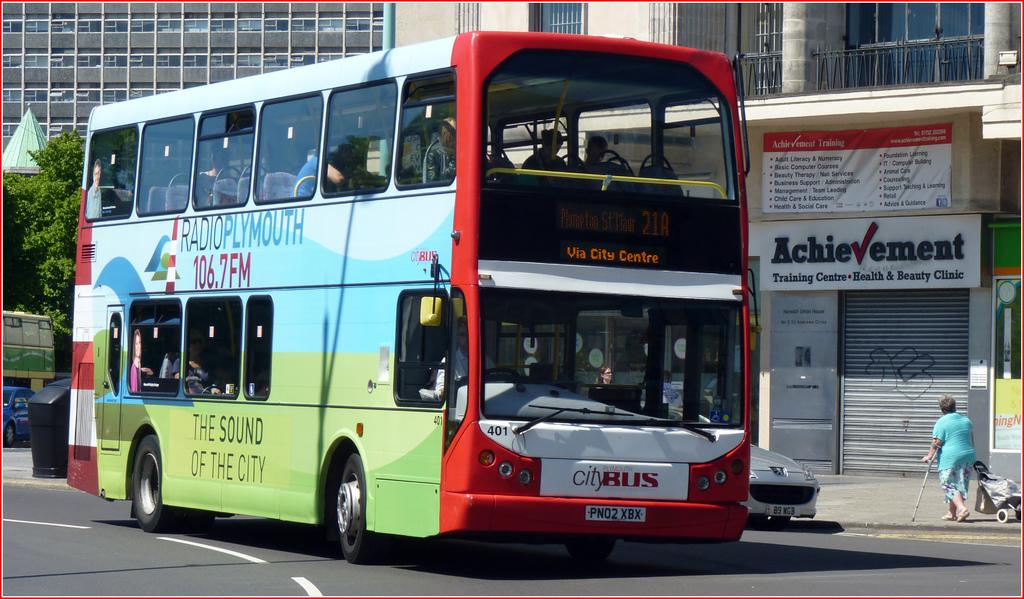<image>
Present a compact description of the photo's key features. A double decker bus with a Radio Plymouth ad on the side. 